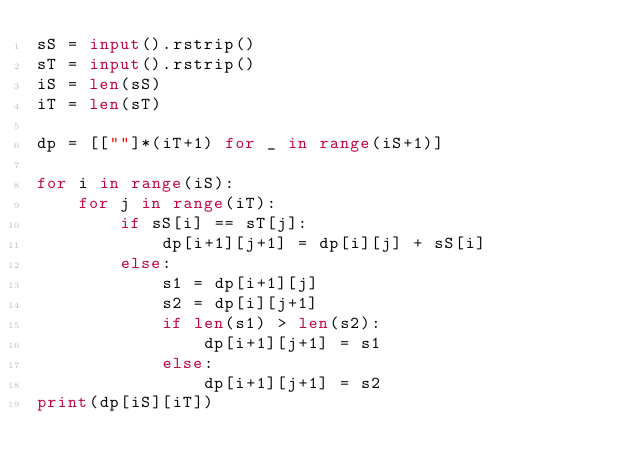<code> <loc_0><loc_0><loc_500><loc_500><_Python_>sS = input().rstrip()
sT = input().rstrip()
iS = len(sS)
iT = len(sT)

dp = [[""]*(iT+1) for _ in range(iS+1)]

for i in range(iS):
    for j in range(iT):
        if sS[i] == sT[j]:
            dp[i+1][j+1] = dp[i][j] + sS[i]
        else:
            s1 = dp[i+1][j]
            s2 = dp[i][j+1]
            if len(s1) > len(s2):
                dp[i+1][j+1] = s1
            else:
                dp[i+1][j+1] = s2
print(dp[iS][iT])
</code> 